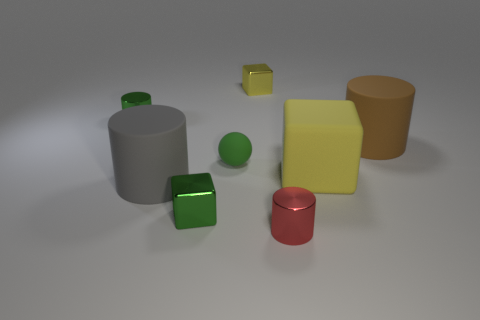Are there any other things that have the same shape as the tiny matte thing?
Your response must be concise. No. Is the number of gray matte objects that are behind the brown rubber thing the same as the number of shiny objects behind the small red metallic cylinder?
Your answer should be very brief. No. The yellow thing behind the metal cylinder left of the tiny yellow shiny thing is made of what material?
Make the answer very short. Metal. How many things are blue matte things or things behind the yellow matte thing?
Provide a succinct answer. 4. There is a green object that is made of the same material as the brown cylinder; what is its size?
Provide a succinct answer. Small. Are there more metal things behind the yellow matte thing than brown cylinders?
Your response must be concise. Yes. What is the size of the cylinder that is both in front of the large yellow rubber cube and right of the green metallic cube?
Your answer should be very brief. Small. There is another tiny yellow thing that is the same shape as the yellow rubber thing; what is it made of?
Ensure brevity in your answer.  Metal. There is a metallic block in front of the gray rubber cylinder; is its size the same as the large gray rubber thing?
Ensure brevity in your answer.  No. There is a cylinder that is behind the red shiny cylinder and to the right of the green metallic block; what color is it?
Offer a very short reply. Brown. 